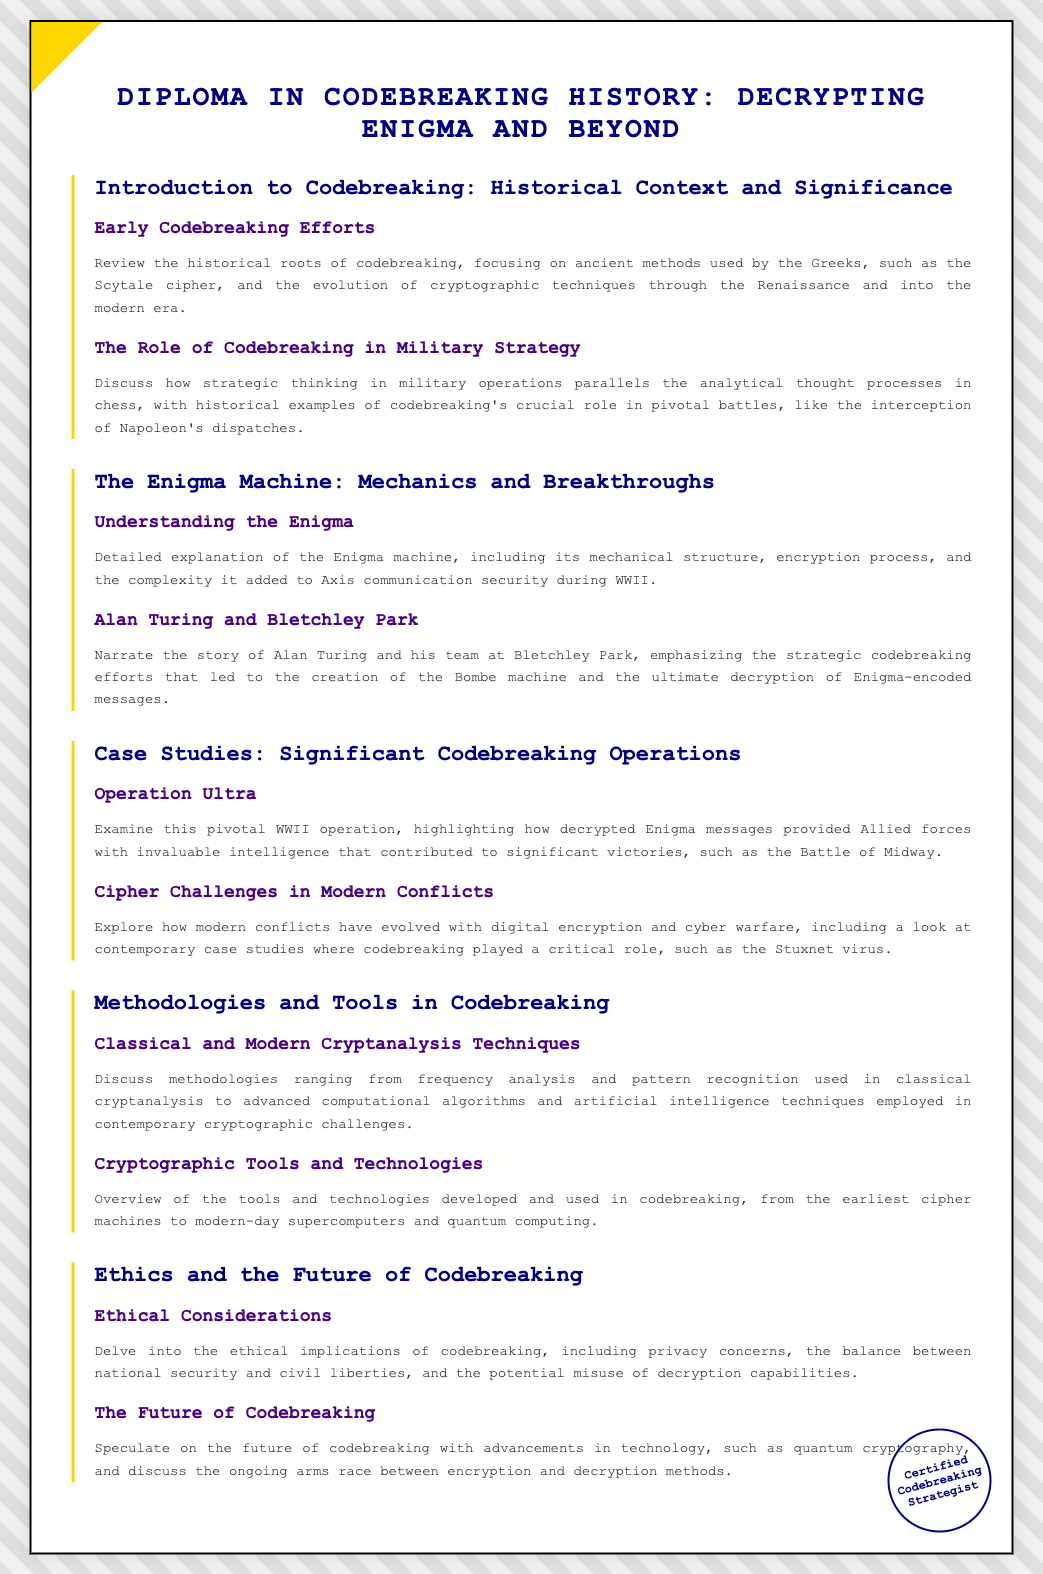What is the title of the diploma? The title is prominently displayed at the top of the document, indicating the subject matter covered.
Answer: Diploma in Codebreaking History: Decrypting Enigma and Beyond Who is a key figure associated with Bletchley Park? The document mentions specific contributions related to codebreaking efforts at Bletchley Park.
Answer: Alan Turing What operation is highlighted as pivotal in WWII? This specific operation is mentioned in the case studies section, showcasing its significance during the war.
Answer: Operation Ultra What type of techniques are discussed in relation to modern cryptanalysis? The methodologies section lists various approaches that are relevant to current challenges in codebreaking.
Answer: Advanced computational algorithms What is a key ethical consideration mentioned in the diploma? The document references potential issues related to the field of codebreaking, specifically addressing societal implications.
Answer: Privacy concerns How many modules are included in the diploma? The number of modules is indicated within the structured sections of the document.
Answer: Five 